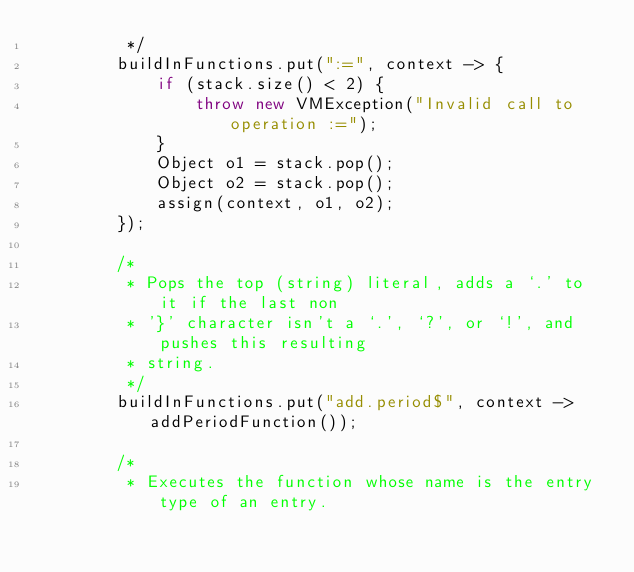<code> <loc_0><loc_0><loc_500><loc_500><_Java_>         */
        buildInFunctions.put(":=", context -> {
            if (stack.size() < 2) {
                throw new VMException("Invalid call to operation :=");
            }
            Object o1 = stack.pop();
            Object o2 = stack.pop();
            assign(context, o1, o2);
        });

        /*
         * Pops the top (string) literal, adds a `.' to it if the last non
         * '}' character isn't a `.', `?', or `!', and pushes this resulting
         * string.
         */
        buildInFunctions.put("add.period$", context -> addPeriodFunction());

        /*
         * Executes the function whose name is the entry type of an entry.</code> 